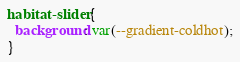<code> <loc_0><loc_0><loc_500><loc_500><_CSS_>habitat-slider {
  background: var(--gradient-coldhot);
}
</code> 